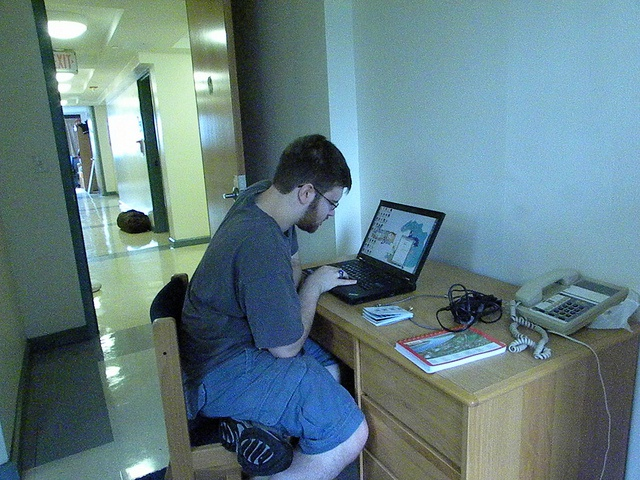Describe the objects in this image and their specific colors. I can see people in teal, black, blue, and navy tones, chair in teal, gray, black, and darkgreen tones, laptop in teal, black, gray, and darkgray tones, book in teal, lightblue, and gray tones, and book in teal, lightblue, and gray tones in this image. 